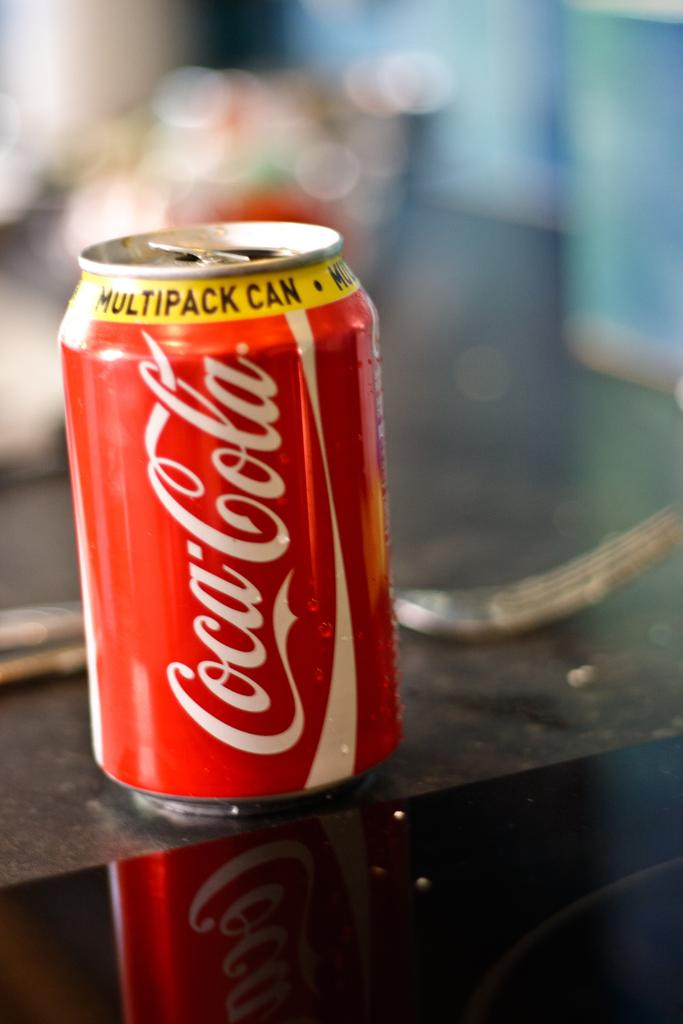Provide a one-sentence caption for the provided image. A Coca Cola can has a yellow band on it reading Multipack Can. 